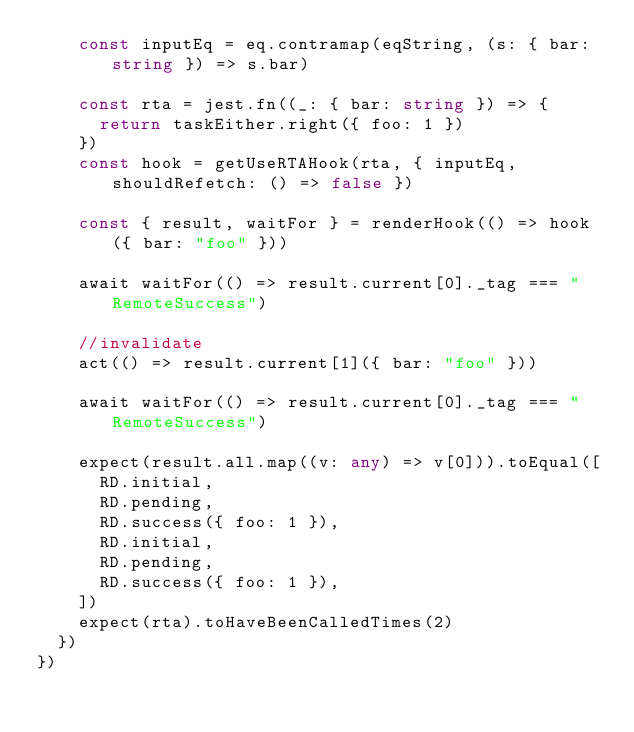<code> <loc_0><loc_0><loc_500><loc_500><_TypeScript_>    const inputEq = eq.contramap(eqString, (s: { bar: string }) => s.bar)

    const rta = jest.fn((_: { bar: string }) => {
      return taskEither.right({ foo: 1 })
    })
    const hook = getUseRTAHook(rta, { inputEq, shouldRefetch: () => false })

    const { result, waitFor } = renderHook(() => hook({ bar: "foo" }))

    await waitFor(() => result.current[0]._tag === "RemoteSuccess")

    //invalidate
    act(() => result.current[1]({ bar: "foo" }))

    await waitFor(() => result.current[0]._tag === "RemoteSuccess")

    expect(result.all.map((v: any) => v[0])).toEqual([
      RD.initial,
      RD.pending,
      RD.success({ foo: 1 }),
      RD.initial,
      RD.pending,
      RD.success({ foo: 1 }),
    ])
    expect(rta).toHaveBeenCalledTimes(2)
  })
})
</code> 